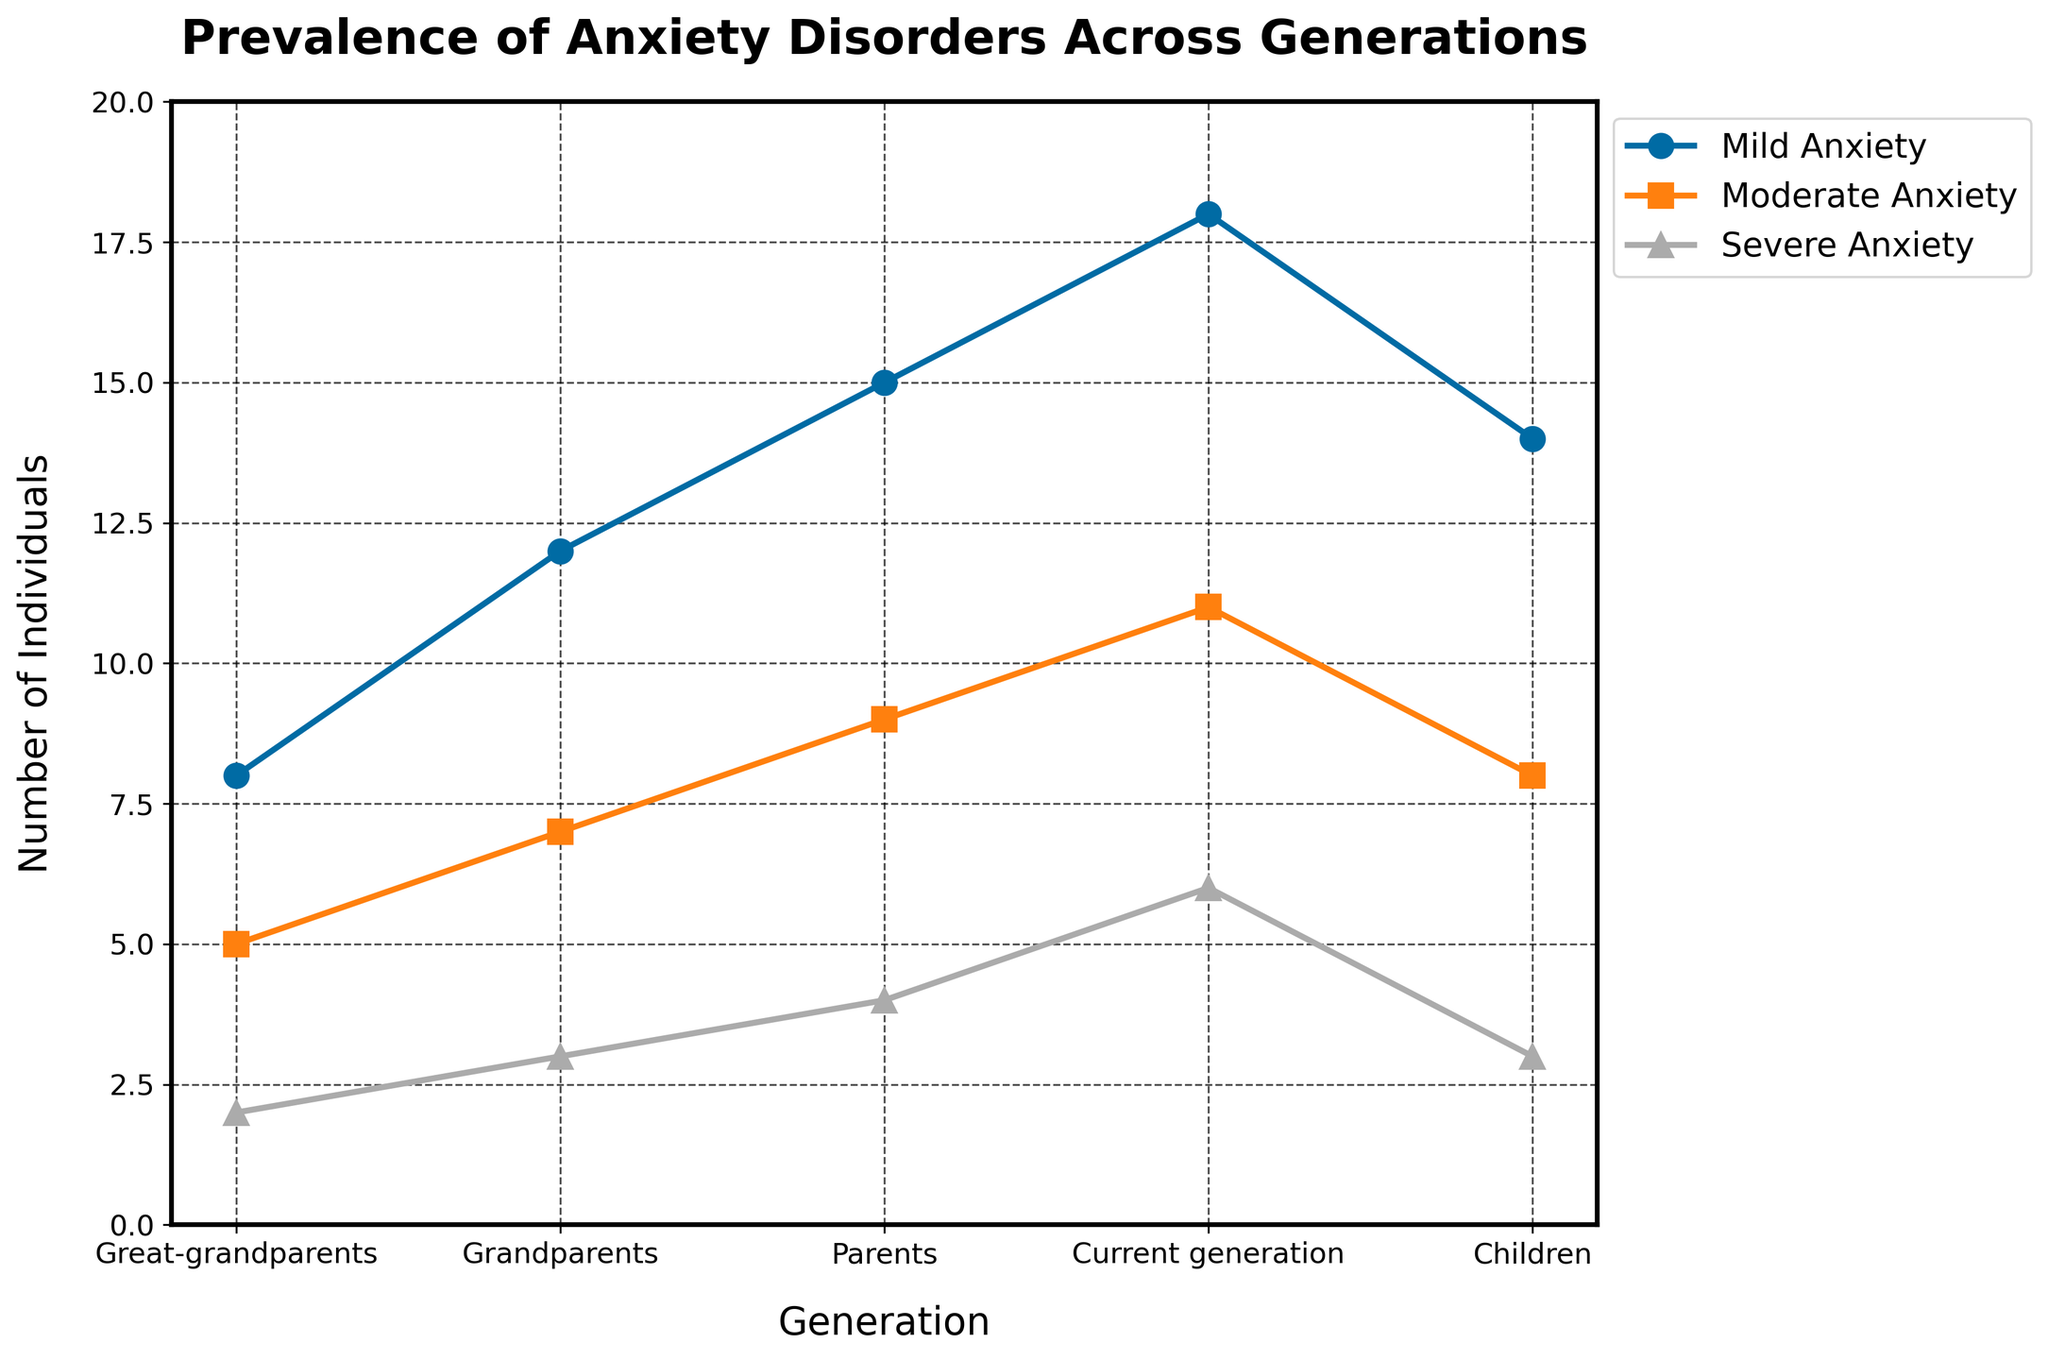What is the difference in the number of individuals with mild anxiety between the grandparents and the children? From the figure, mild anxiety is represented by a line marked with circles. For the grandparents, the number of individuals with mild anxiety is 12. For the children, it is 14. The difference is calculated as 14 - 12.
Answer: 2 Which generation has the highest number of individuals with severe anxiety? Severe anxiety is represented by the line marked with triangles. By comparing all the points on this line, the current generation has the highest value, with 6 individuals.
Answer: Current generation What is the average number of individuals with moderate anxiety across all generations? Moderate anxiety is marked by squares. The values are 5, 7, 9, 11, and 8. Summing these gives 5 + 7 + 9 + 11 + 8 = 40. Since there are five generations, the average is 40/5.
Answer: 8 Compare the trend of mild and moderate anxiety from the parents' to the current generation. Which one increased more sharply? From the figure, the line for mild anxiety (circles) goes from 15 to 18, a change of 3. For moderate anxiety (squares), the change is from 9 to 11, a change of 2. The increase in mild anxiety is sharper by 1.
Answer: Mild anxiety How many more individuals have severe anxiety in the current generation compared to the great-grandparents? Severe anxiety is identified with triangles. The current generation has 6 individuals, while the great-grandparents have 2. The difference is 6 - 2.
Answer: 4 Out of all generations, which one reported the lowest number of individuals with any severity of anxiety and what is the sum of those individuals? By examining the number of individuals for each type of anxiety, the great-grandparents have the lowest totals: 8 (mild) + 5 (moderate) + 2 (severe). Summing these gives 8 + 5 + 2.
Answer: Great-grandparents, 15 What is the total number of individuals with mild anxiety across all generations? Adding the number of individuals with mild anxiety across all generations: 8 (great-grandparents) + 12 (grandparents) + 15 (parents) + 18 (current generation) + 14 (children). The sum is 8 + 12 + 15 + 18 + 14.
Answer: 67 How does the number of individuals with moderate anxiety in the grandparents generation compare to the children generation? Looking at the line for moderate anxiety (squares), the grandparents have 7 individuals, and the children have 8 individuals. Comparing 7 and 8, children have one more.
Answer: Children have 1 more 